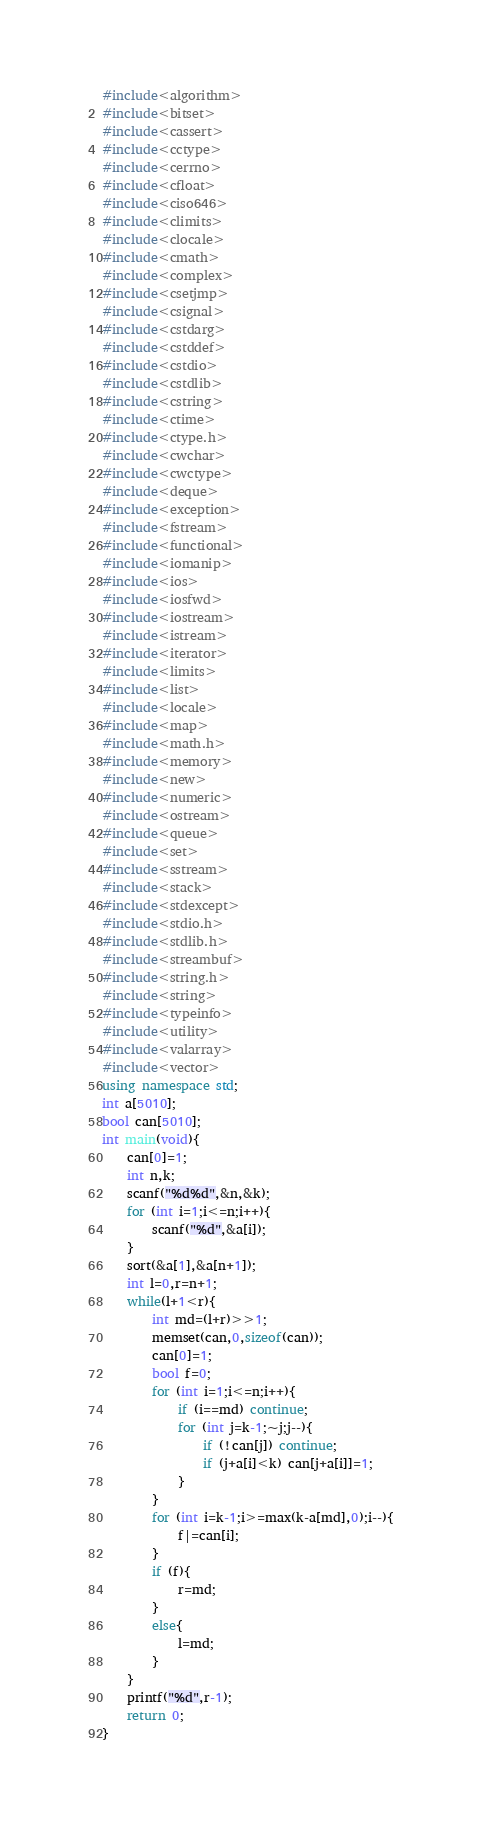<code> <loc_0><loc_0><loc_500><loc_500><_C++_>#include<algorithm>
#include<bitset>
#include<cassert>
#include<cctype>
#include<cerrno>
#include<cfloat>
#include<ciso646>
#include<climits>
#include<clocale>
#include<cmath>
#include<complex>
#include<csetjmp>
#include<csignal>
#include<cstdarg>
#include<cstddef>
#include<cstdio>
#include<cstdlib>
#include<cstring>
#include<ctime>
#include<ctype.h>
#include<cwchar>
#include<cwctype>
#include<deque>
#include<exception>
#include<fstream>
#include<functional>
#include<iomanip>
#include<ios>
#include<iosfwd>
#include<iostream>
#include<istream>
#include<iterator>
#include<limits>
#include<list>
#include<locale>
#include<map>
#include<math.h>
#include<memory>
#include<new>
#include<numeric>
#include<ostream>
#include<queue>
#include<set>
#include<sstream>
#include<stack>
#include<stdexcept>
#include<stdio.h>
#include<stdlib.h>
#include<streambuf>
#include<string.h>
#include<string>
#include<typeinfo>
#include<utility>
#include<valarray>
#include<vector>
using namespace std;
int a[5010];
bool can[5010];
int main(void){
	can[0]=1;
	int n,k;
	scanf("%d%d",&n,&k);
	for (int i=1;i<=n;i++){
		scanf("%d",&a[i]);
	}
	sort(&a[1],&a[n+1]);
	int l=0,r=n+1;
	while(l+1<r){
		int md=(l+r)>>1;
		memset(can,0,sizeof(can));
		can[0]=1;
		bool f=0;
		for (int i=1;i<=n;i++){
			if (i==md) continue;
			for (int j=k-1;~j;j--){
				if (!can[j]) continue;
				if (j+a[i]<k) can[j+a[i]]=1;
			}
		}
		for (int i=k-1;i>=max(k-a[md],0);i--){
			f|=can[i];
		}
		if (f){
			r=md;
		}
		else{
			l=md;
		}
	}
	printf("%d",r-1);
	return 0;
}</code> 